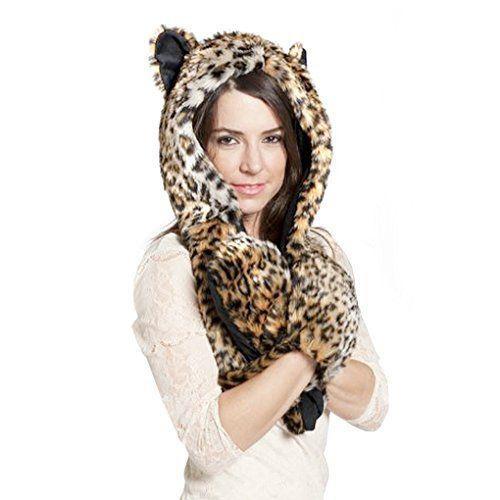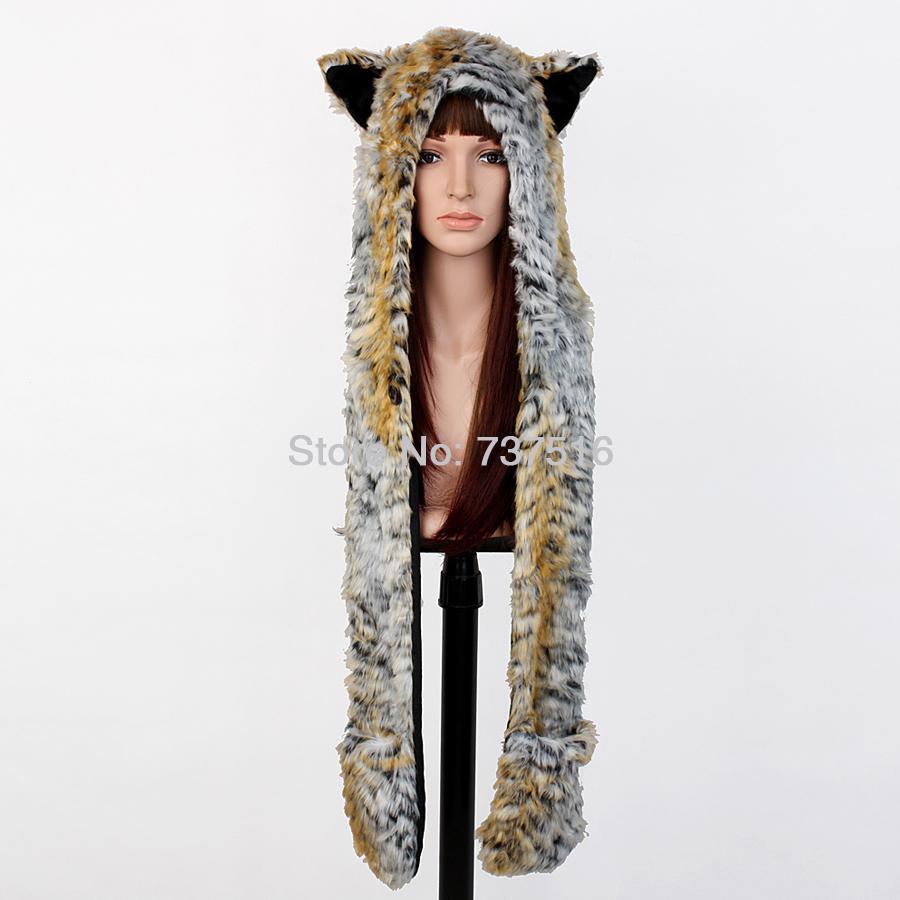The first image is the image on the left, the second image is the image on the right. Considering the images on both sides, is "At least one of the hats has a giraffe print." valid? Answer yes or no. No. 